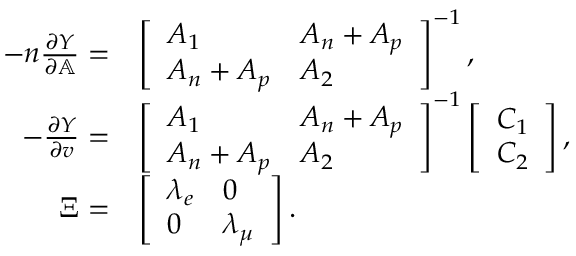<formula> <loc_0><loc_0><loc_500><loc_500>\begin{array} { r l } { - n \frac { \partial Y } { \partial \mathbb { A } } = } & { \left [ \begin{array} { l l } { A _ { 1 } } & { A _ { n } + A _ { p } } \\ { A _ { n } + A _ { p } } & { A _ { 2 } } \end{array} \right ] ^ { - 1 } , } \\ { - \frac { \partial Y } { \partial v } = } & { \left [ \begin{array} { l l } { A _ { 1 } } & { A _ { n } + A _ { p } } \\ { A _ { n } + A _ { p } } & { A _ { 2 } } \end{array} \right ] ^ { - 1 } \left [ \begin{array} { l } { C _ { 1 } } \\ { C _ { 2 } } \end{array} \right ] , } \\ { \Xi = } & { \left [ \begin{array} { l l } { \lambda _ { e } } & { 0 } \\ { 0 } & { \lambda _ { \mu } } \end{array} \right ] . } \end{array}</formula> 